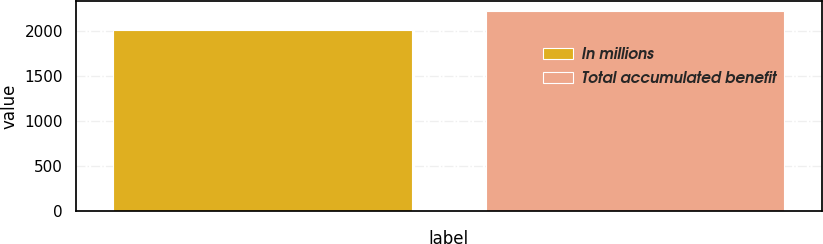Convert chart to OTSL. <chart><loc_0><loc_0><loc_500><loc_500><bar_chart><fcel>In millions<fcel>Total accumulated benefit<nl><fcel>2013<fcel>2231<nl></chart> 